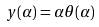Convert formula to latex. <formula><loc_0><loc_0><loc_500><loc_500>y ( \alpha ) = \alpha \theta ( \alpha )</formula> 